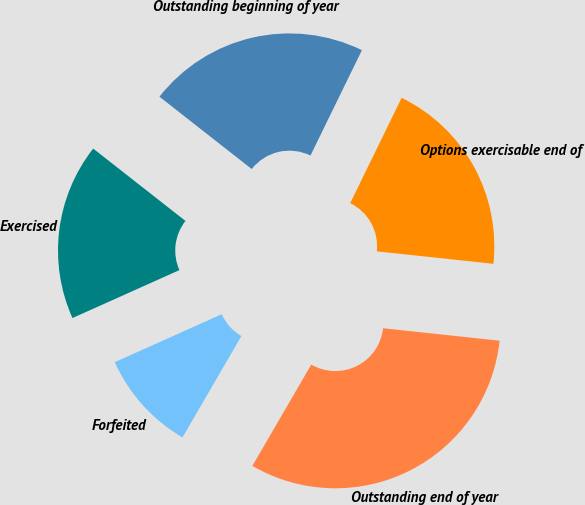Convert chart to OTSL. <chart><loc_0><loc_0><loc_500><loc_500><pie_chart><fcel>Outstanding beginning of year<fcel>Exercised<fcel>Forfeited<fcel>Outstanding end of year<fcel>Options exercisable end of<nl><fcel>21.65%<fcel>17.29%<fcel>9.91%<fcel>31.69%<fcel>19.47%<nl></chart> 